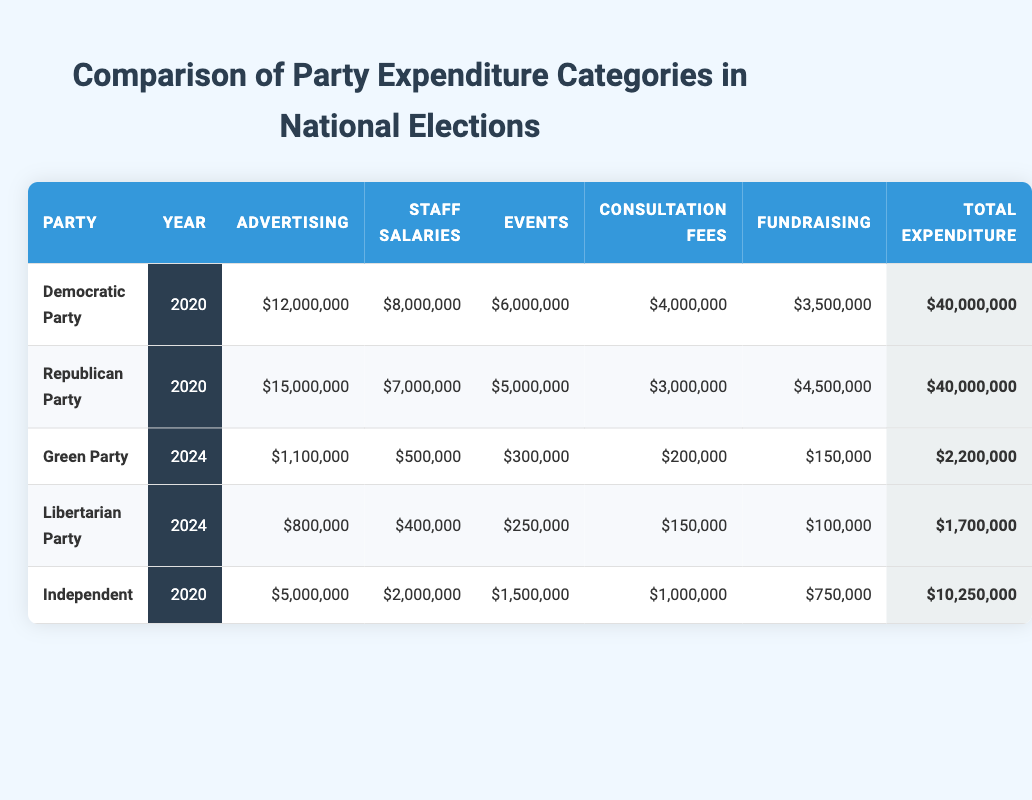What is the total expenditure of the Republican Party in 2020? The table shows that the Republican Party had a total expenditure of $40,000,000 in 2020. This value is found directly under the "Total Expenditure" column aligned with the Republican Party row for 2020.
Answer: 40,000,000 Which party had the highest advertising expenditure in 2020? In 2020, the Republican Party had the highest advertising expenditure of $15,000,000. By comparing the "Advertising" column values of the Democratic Party ($12,000,000) and the Independent ($5,000,000), it can be seen that the Republican Party led.
Answer: Republican Party What is the difference in total expenditure between the Green Party and the Libertarian Party in 2024? The total expenditure for the Green Party in 2024 is $2,200,000, while the Libertarian Party's total expenditure is $1,700,000. The difference can be calculated by subtracting the Libertarian Party's total from the Green Party's total: $2,200,000 - $1,700,000 = $500,000.
Answer: 500,000 Did the Independent Party spend more on staff salaries than the Green Party in 2024? The Independent Party spent $2,000,000 on staff salaries in 2020, while the Green Party did not spend any money on staff salaries in 2024, spending only $500,000 overall on staff salaries. Therefore, yes, the Independent Party spent more.
Answer: Yes What is the average expenditure on events across all parties that participated in the 2020 elections? The expenditure on events for parties in 2020 is as follows: Democratic Party - $6,000,000, Republican Party - $5,000,000, and Independent - $1,500,000. To find the average, we sum these amounts: $6,000,000 + $5,000,000 + $1,500,000 = $12,500,000. Then we divide this by the number of parties (3): $12,500,000 / 3 = $4,166,667.
Answer: 4,166,667 What percentage of the total expenditure did advertising account for in the Democratic Party for 2020? The Democratic Party's total expenditure is $40,000,000, and the advertising expenditure was $12,000,000. To find the percentage, we divide the advertising by total expenditure: ($12,000,000 / $40,000,000) * 100 = 30%.
Answer: 30% 